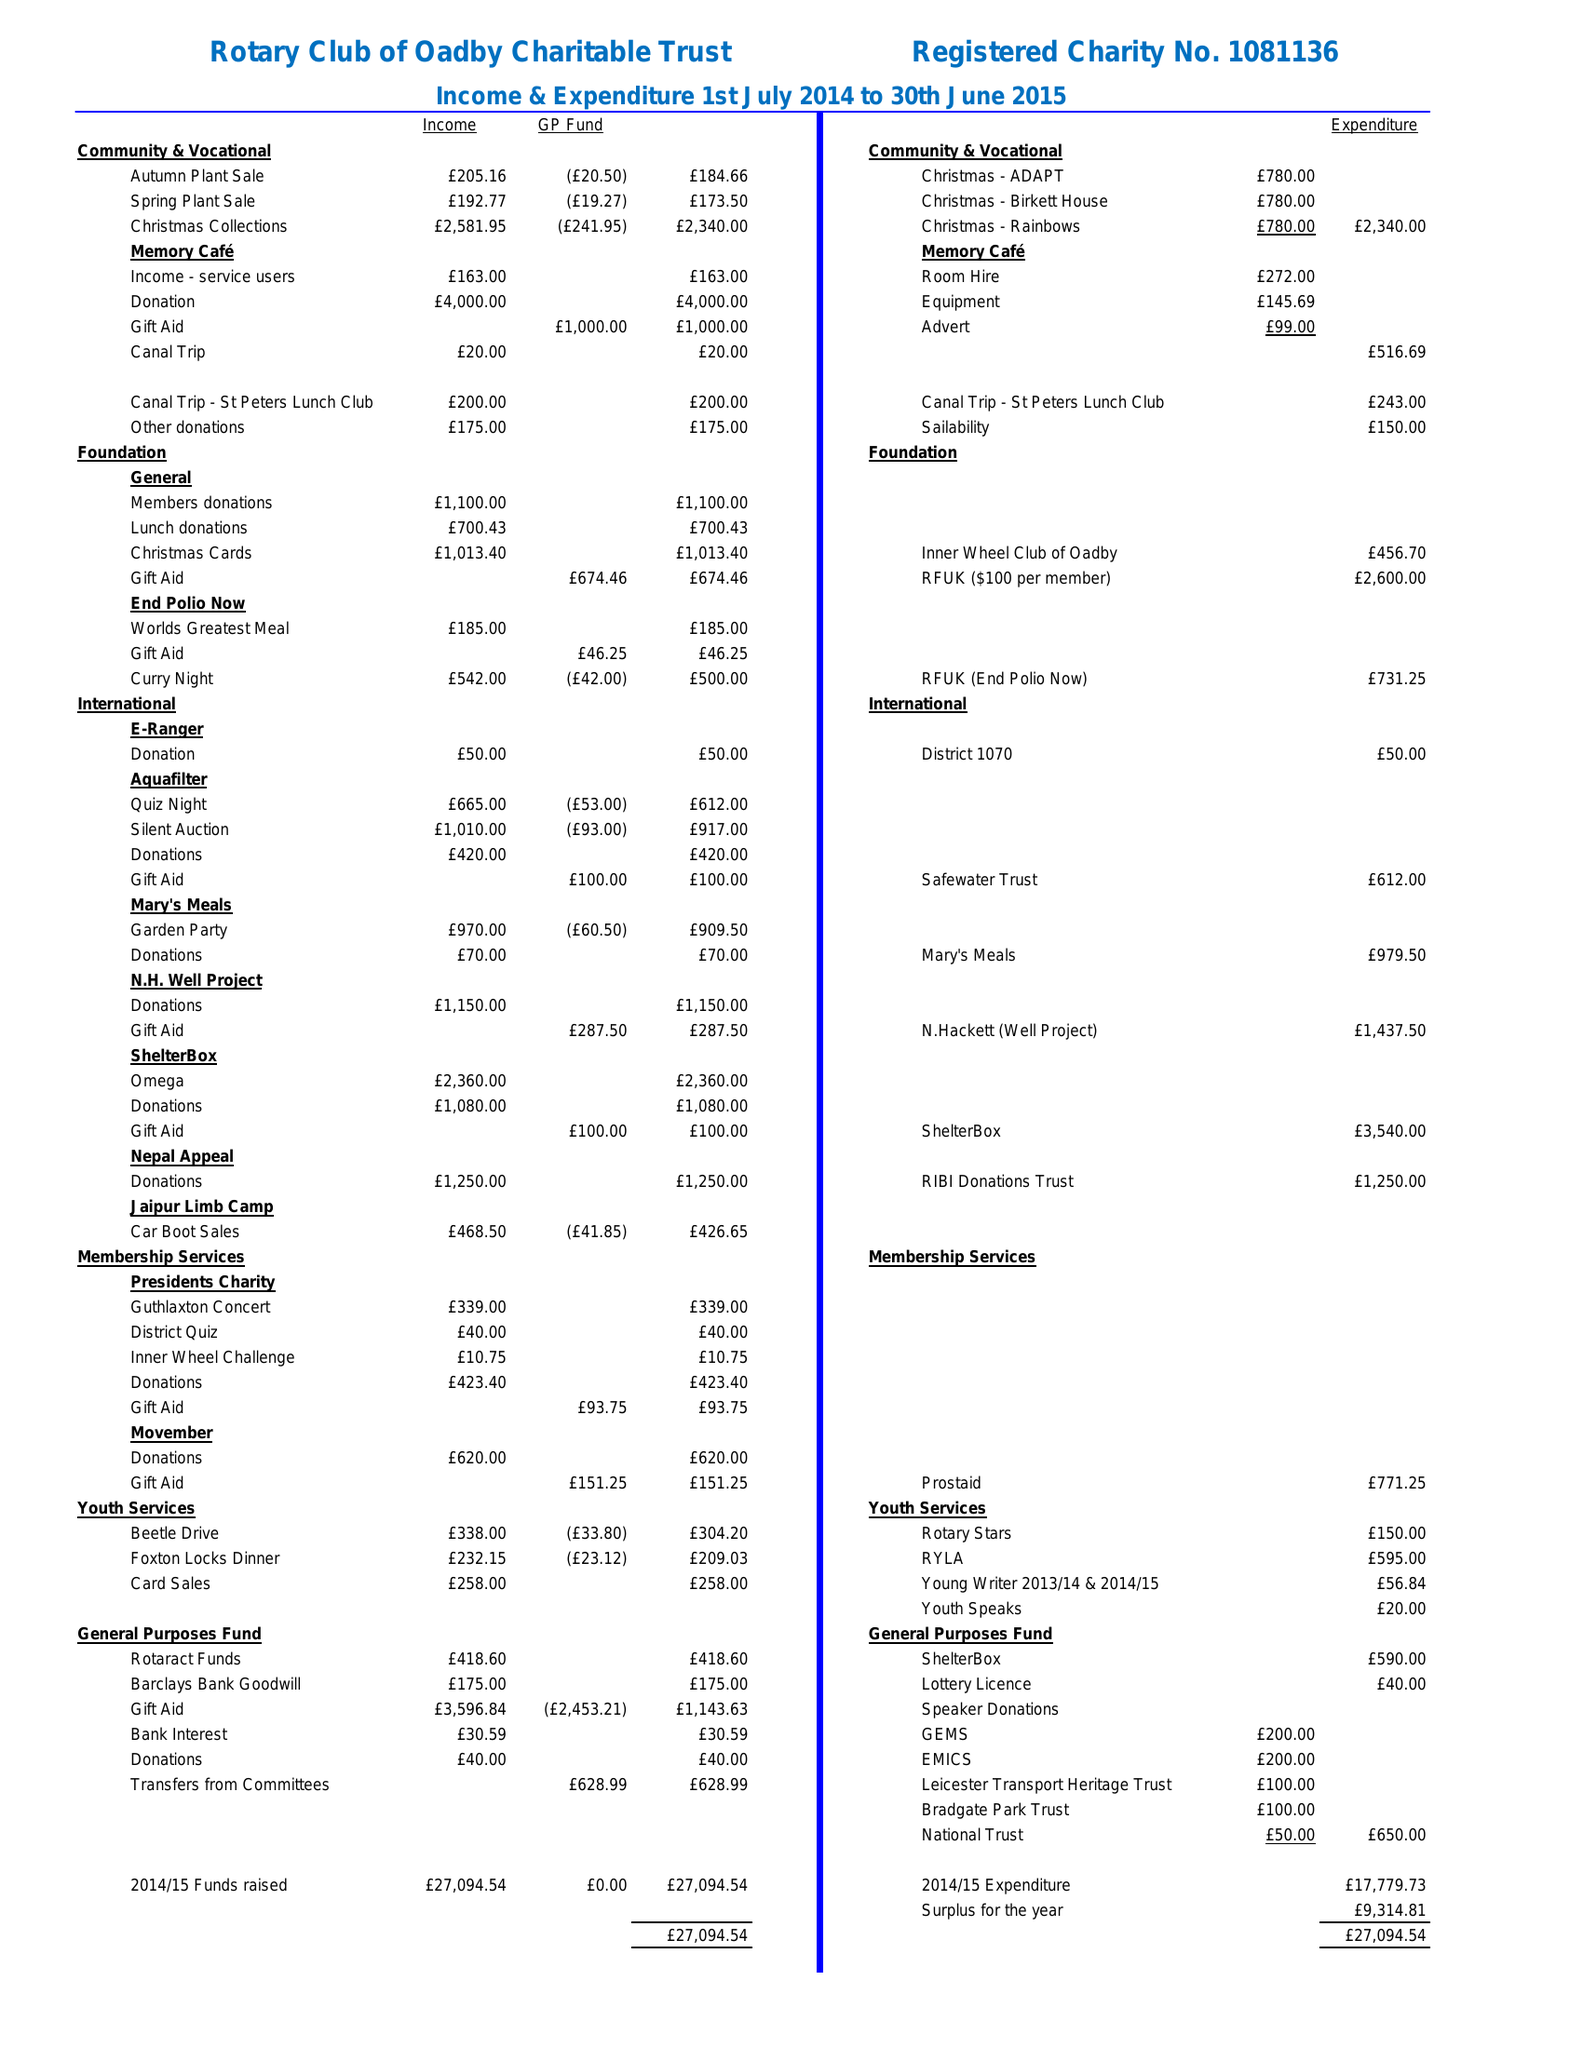What is the value for the income_annually_in_british_pounds?
Answer the question using a single word or phrase. 27094.00 